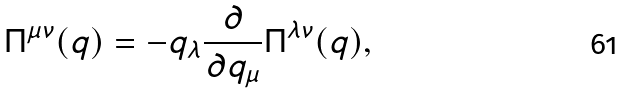<formula> <loc_0><loc_0><loc_500><loc_500>\Pi ^ { \mu \nu } ( q ) = - q _ { \lambda } \frac { \partial } { \partial q _ { \mu } } \Pi ^ { \lambda \nu } ( q ) ,</formula> 